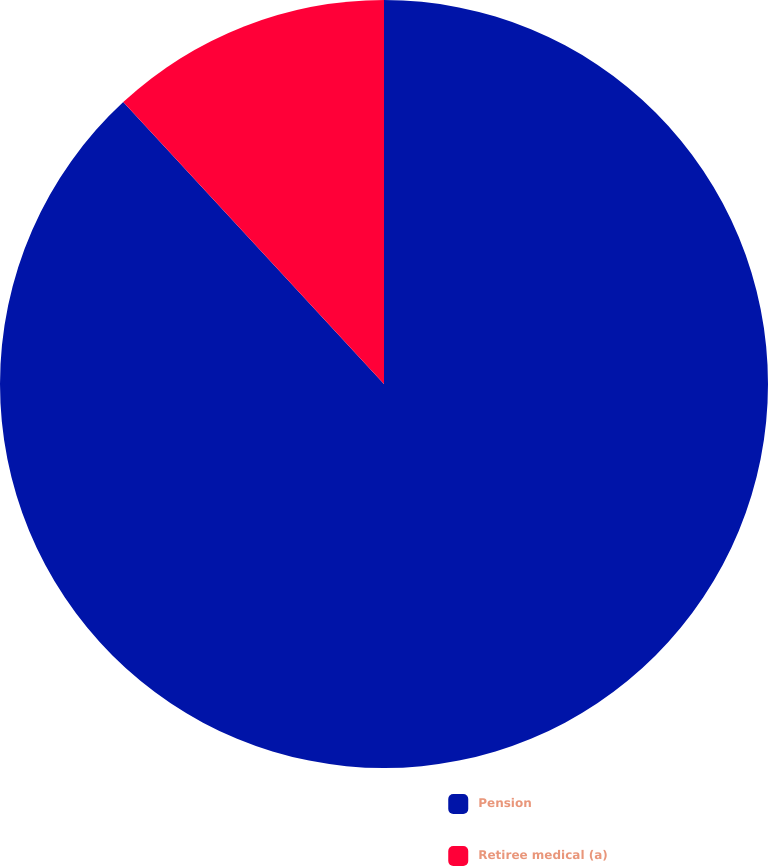<chart> <loc_0><loc_0><loc_500><loc_500><pie_chart><fcel>Pension<fcel>Retiree medical (a)<nl><fcel>88.12%<fcel>11.88%<nl></chart> 